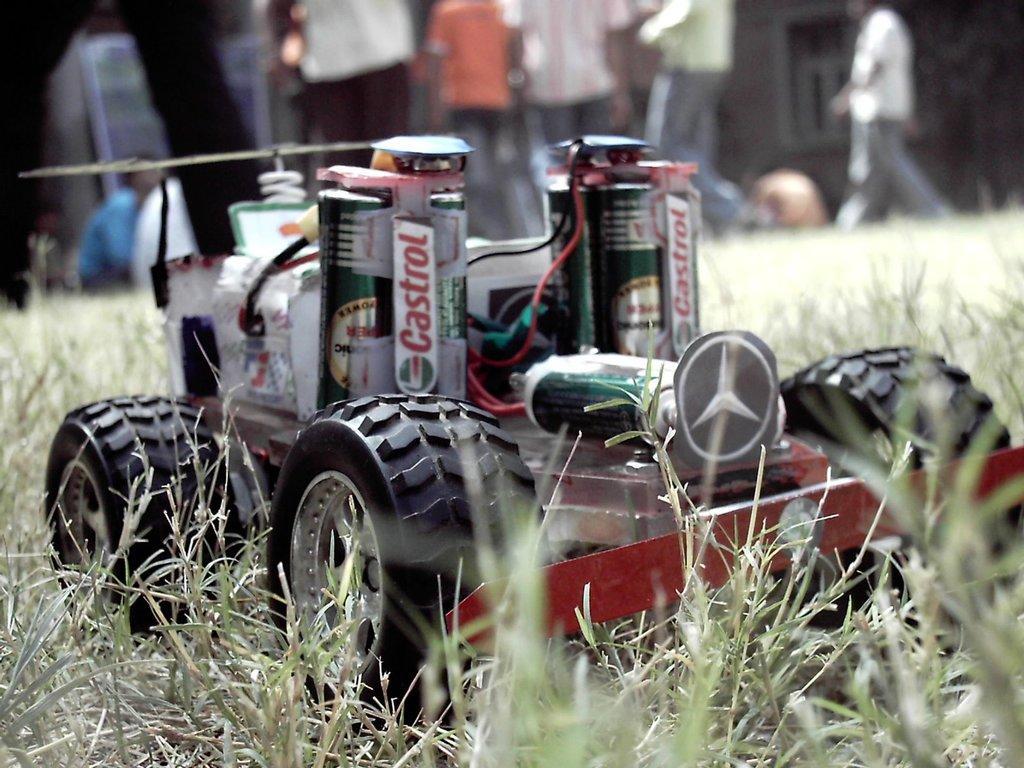Please provide a concise description of this image. In this image there is a remote car on a grassland, in the background there are people standing and it is blurred. 